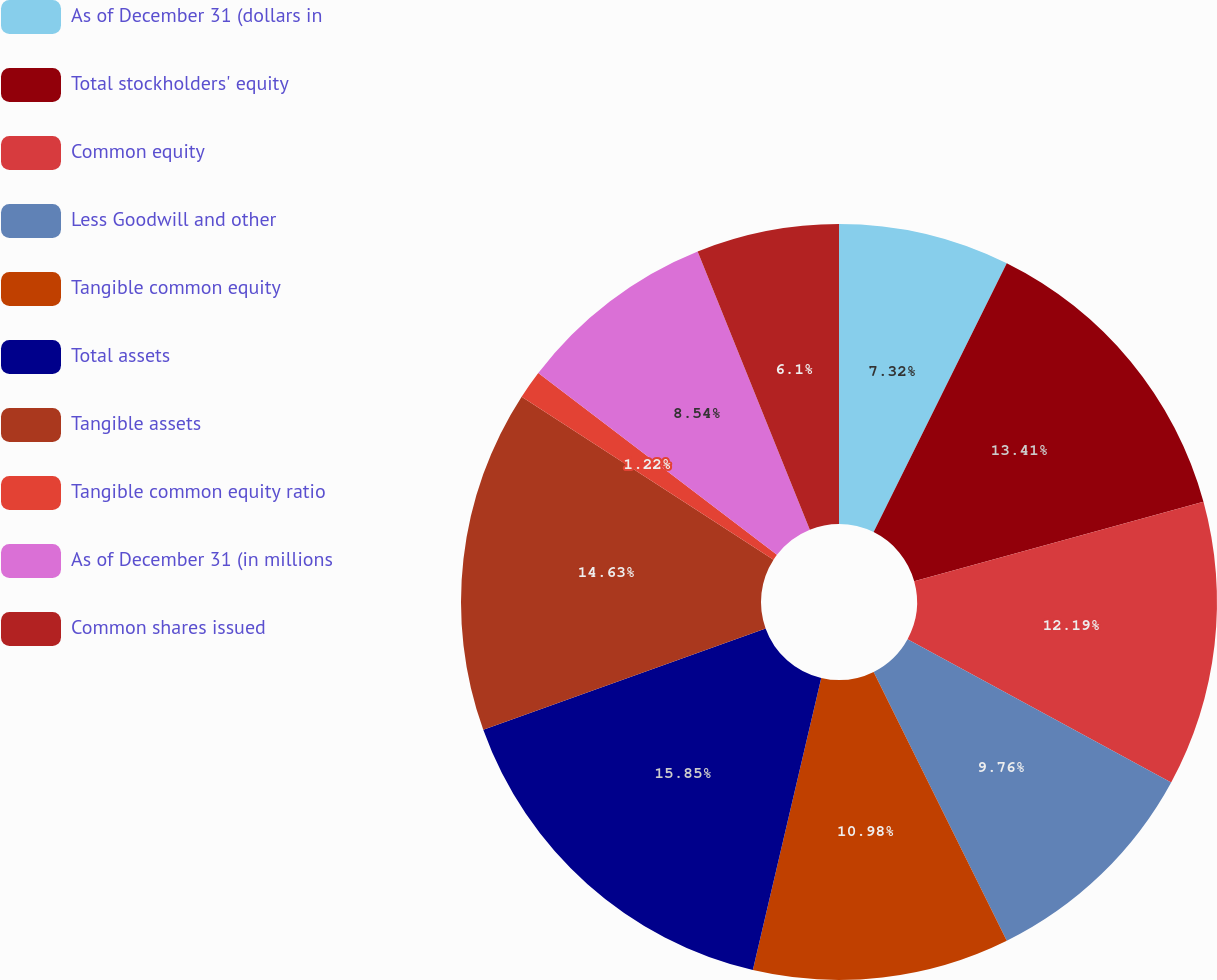Convert chart to OTSL. <chart><loc_0><loc_0><loc_500><loc_500><pie_chart><fcel>As of December 31 (dollars in<fcel>Total stockholders' equity<fcel>Common equity<fcel>Less Goodwill and other<fcel>Tangible common equity<fcel>Total assets<fcel>Tangible assets<fcel>Tangible common equity ratio<fcel>As of December 31 (in millions<fcel>Common shares issued<nl><fcel>7.32%<fcel>13.41%<fcel>12.19%<fcel>9.76%<fcel>10.98%<fcel>15.85%<fcel>14.63%<fcel>1.22%<fcel>8.54%<fcel>6.1%<nl></chart> 